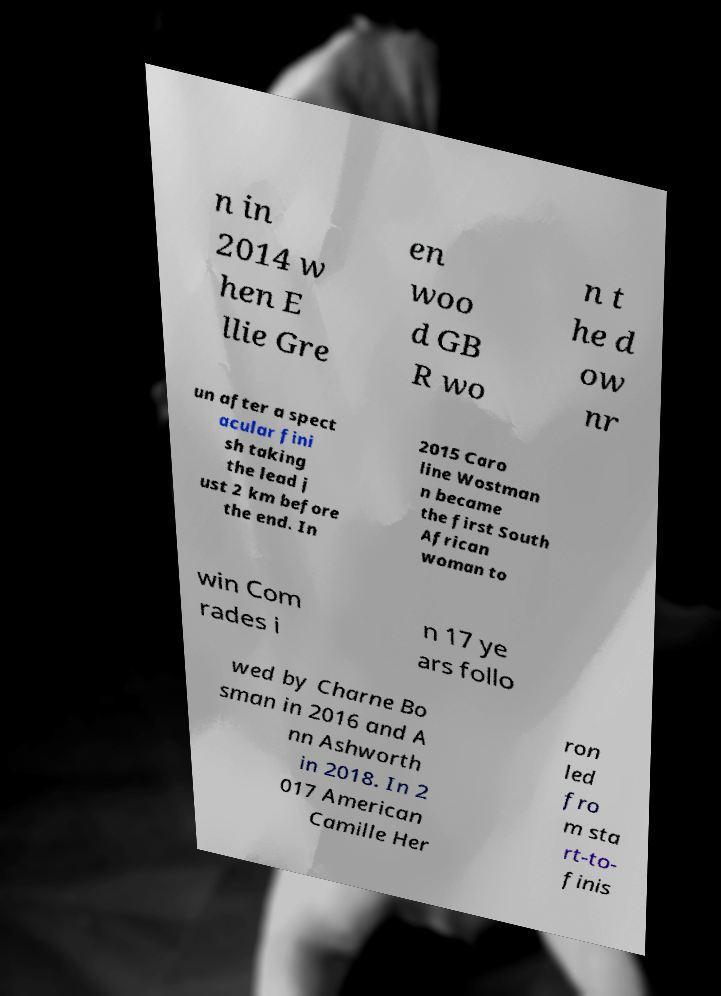I need the written content from this picture converted into text. Can you do that? n in 2014 w hen E llie Gre en woo d GB R wo n t he d ow nr un after a spect acular fini sh taking the lead j ust 2 km before the end. In 2015 Caro line Wostman n became the first South African woman to win Com rades i n 17 ye ars follo wed by Charne Bo sman in 2016 and A nn Ashworth in 2018. In 2 017 American Camille Her ron led fro m sta rt-to- finis 